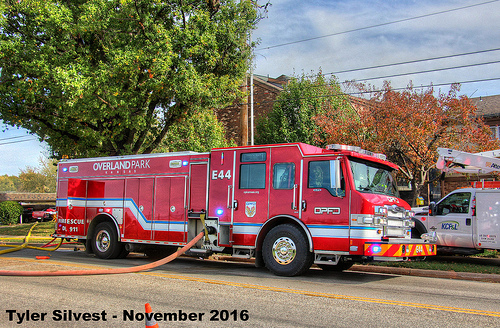<image>
Is the hose on the fire truck? No. The hose is not positioned on the fire truck. They may be near each other, but the hose is not supported by or resting on top of the fire truck. Is there a fire hose in the fire truck? Yes. The fire hose is contained within or inside the fire truck, showing a containment relationship. 